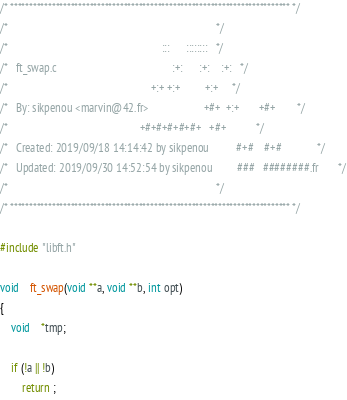<code> <loc_0><loc_0><loc_500><loc_500><_C_>/* ************************************************************************** */
/*                                                                            */
/*                                                        :::      ::::::::   */
/*   ft_swap.c                                          :+:      :+:    :+:   */
/*                                                    +:+ +:+         +:+     */
/*   By: sikpenou <marvin@42.fr>                    +#+  +:+       +#+        */
/*                                                +#+#+#+#+#+   +#+           */
/*   Created: 2019/09/18 14:14:42 by sikpenou          #+#    #+#             */
/*   Updated: 2019/09/30 14:52:54 by sikpenou         ###   ########.fr       */
/*                                                                            */
/* ************************************************************************** */

#include "libft.h"

void	ft_swap(void **a, void **b, int opt)
{
	void	*tmp;

	if (!a || !b)
		return ;</code> 